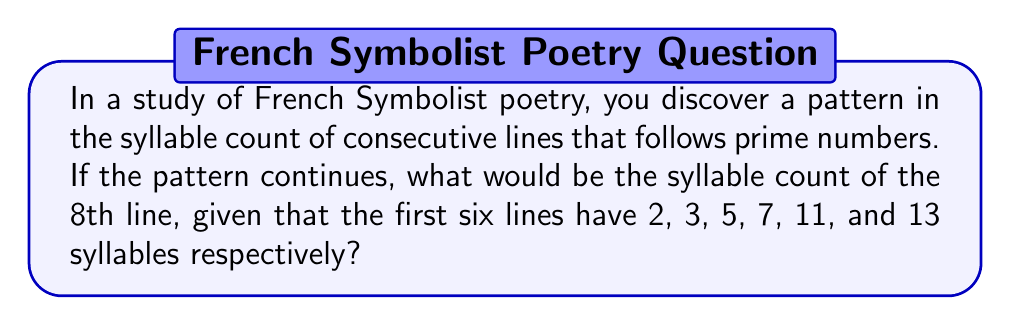Help me with this question. To solve this problem, we need to follow these steps:

1. Recognize the pattern: The syllable counts form a sequence of prime numbers.

2. List out the first few prime numbers:
   $2, 3, 5, 7, 11, 13, 17, 19, 23, 29, ...$

3. Identify the given sequence:
   Line 1: 2 syllables
   Line 2: 3 syllables
   Line 3: 5 syllables
   Line 4: 7 syllables
   Line 5: 11 syllables
   Line 6: 13 syllables

4. Determine the next prime numbers in the sequence:
   Line 7 would have 17 syllables
   Line 8 would have 19 syllables

Therefore, the 8th line of the poem would have 19 syllables if the pattern continues.

This sequence reflects the mathematical precision often found in French Symbolist poetry, drawing a parallel between the structure of verse and the abstract beauty of prime numbers, much like the precise yet evocative brushstrokes in Impressionist paintings.
Answer: 19 